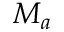Convert formula to latex. <formula><loc_0><loc_0><loc_500><loc_500>M _ { a }</formula> 